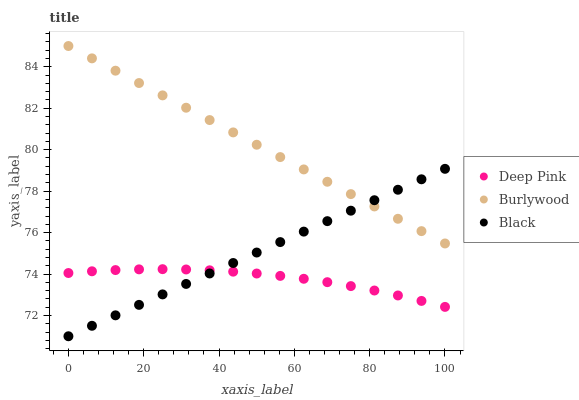Does Deep Pink have the minimum area under the curve?
Answer yes or no. Yes. Does Burlywood have the maximum area under the curve?
Answer yes or no. Yes. Does Black have the minimum area under the curve?
Answer yes or no. No. Does Black have the maximum area under the curve?
Answer yes or no. No. Is Burlywood the smoothest?
Answer yes or no. Yes. Is Deep Pink the roughest?
Answer yes or no. Yes. Is Black the smoothest?
Answer yes or no. No. Is Black the roughest?
Answer yes or no. No. Does Black have the lowest value?
Answer yes or no. Yes. Does Deep Pink have the lowest value?
Answer yes or no. No. Does Burlywood have the highest value?
Answer yes or no. Yes. Does Black have the highest value?
Answer yes or no. No. Is Deep Pink less than Burlywood?
Answer yes or no. Yes. Is Burlywood greater than Deep Pink?
Answer yes or no. Yes. Does Deep Pink intersect Black?
Answer yes or no. Yes. Is Deep Pink less than Black?
Answer yes or no. No. Is Deep Pink greater than Black?
Answer yes or no. No. Does Deep Pink intersect Burlywood?
Answer yes or no. No. 